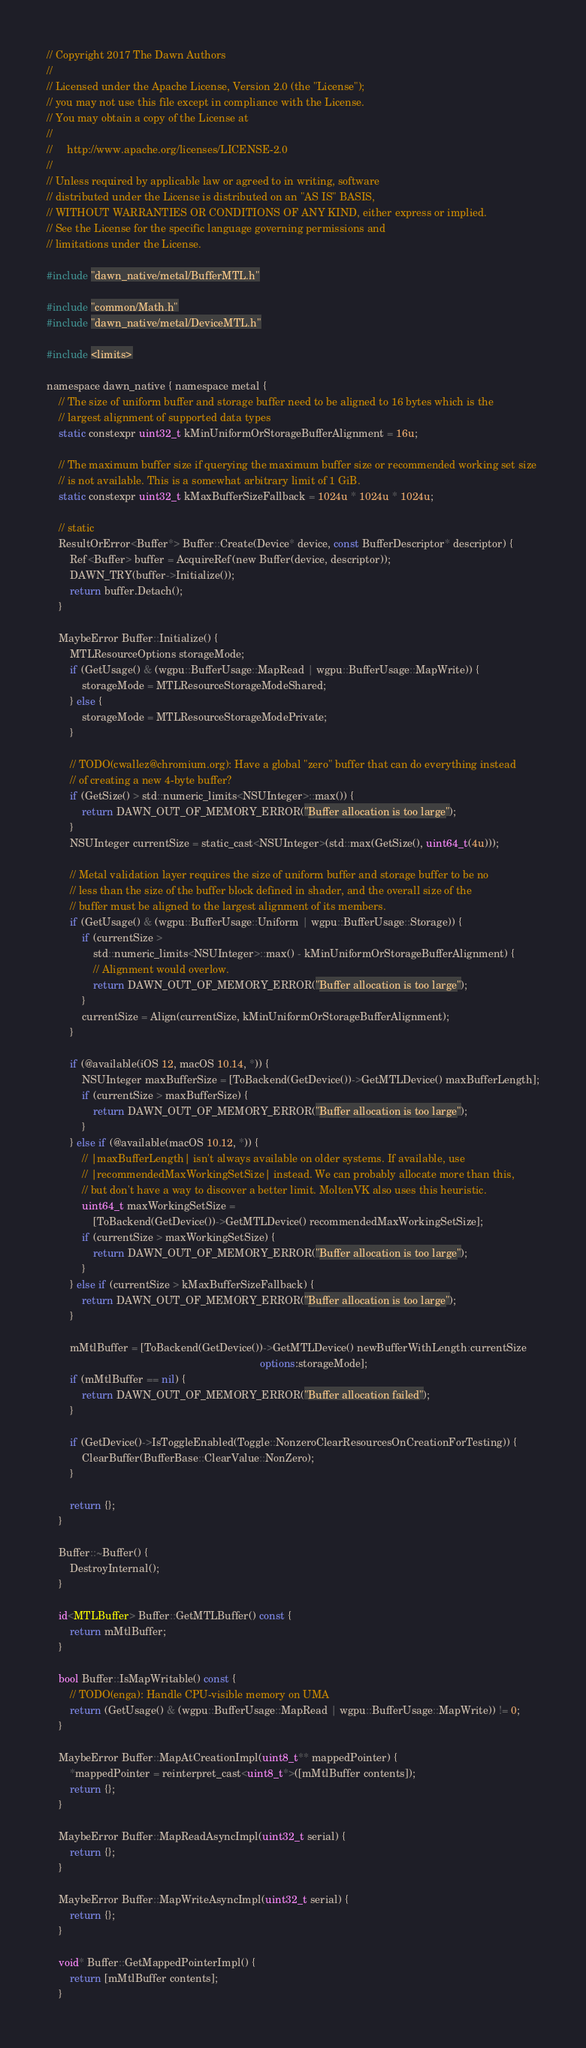<code> <loc_0><loc_0><loc_500><loc_500><_ObjectiveC_>// Copyright 2017 The Dawn Authors
//
// Licensed under the Apache License, Version 2.0 (the "License");
// you may not use this file except in compliance with the License.
// You may obtain a copy of the License at
//
//     http://www.apache.org/licenses/LICENSE-2.0
//
// Unless required by applicable law or agreed to in writing, software
// distributed under the License is distributed on an "AS IS" BASIS,
// WITHOUT WARRANTIES OR CONDITIONS OF ANY KIND, either express or implied.
// See the License for the specific language governing permissions and
// limitations under the License.

#include "dawn_native/metal/BufferMTL.h"

#include "common/Math.h"
#include "dawn_native/metal/DeviceMTL.h"

#include <limits>

namespace dawn_native { namespace metal {
    // The size of uniform buffer and storage buffer need to be aligned to 16 bytes which is the
    // largest alignment of supported data types
    static constexpr uint32_t kMinUniformOrStorageBufferAlignment = 16u;

    // The maximum buffer size if querying the maximum buffer size or recommended working set size
    // is not available. This is a somewhat arbitrary limit of 1 GiB.
    static constexpr uint32_t kMaxBufferSizeFallback = 1024u * 1024u * 1024u;

    // static
    ResultOrError<Buffer*> Buffer::Create(Device* device, const BufferDescriptor* descriptor) {
        Ref<Buffer> buffer = AcquireRef(new Buffer(device, descriptor));
        DAWN_TRY(buffer->Initialize());
        return buffer.Detach();
    }

    MaybeError Buffer::Initialize() {
        MTLResourceOptions storageMode;
        if (GetUsage() & (wgpu::BufferUsage::MapRead | wgpu::BufferUsage::MapWrite)) {
            storageMode = MTLResourceStorageModeShared;
        } else {
            storageMode = MTLResourceStorageModePrivate;
        }

        // TODO(cwallez@chromium.org): Have a global "zero" buffer that can do everything instead
        // of creating a new 4-byte buffer?
        if (GetSize() > std::numeric_limits<NSUInteger>::max()) {
            return DAWN_OUT_OF_MEMORY_ERROR("Buffer allocation is too large");
        }
        NSUInteger currentSize = static_cast<NSUInteger>(std::max(GetSize(), uint64_t(4u)));

        // Metal validation layer requires the size of uniform buffer and storage buffer to be no
        // less than the size of the buffer block defined in shader, and the overall size of the
        // buffer must be aligned to the largest alignment of its members.
        if (GetUsage() & (wgpu::BufferUsage::Uniform | wgpu::BufferUsage::Storage)) {
            if (currentSize >
                std::numeric_limits<NSUInteger>::max() - kMinUniformOrStorageBufferAlignment) {
                // Alignment would overlow.
                return DAWN_OUT_OF_MEMORY_ERROR("Buffer allocation is too large");
            }
            currentSize = Align(currentSize, kMinUniformOrStorageBufferAlignment);
        }

        if (@available(iOS 12, macOS 10.14, *)) {
            NSUInteger maxBufferSize = [ToBackend(GetDevice())->GetMTLDevice() maxBufferLength];
            if (currentSize > maxBufferSize) {
                return DAWN_OUT_OF_MEMORY_ERROR("Buffer allocation is too large");
            }
        } else if (@available(macOS 10.12, *)) {
            // |maxBufferLength| isn't always available on older systems. If available, use
            // |recommendedMaxWorkingSetSize| instead. We can probably allocate more than this,
            // but don't have a way to discover a better limit. MoltenVK also uses this heuristic.
            uint64_t maxWorkingSetSize =
                [ToBackend(GetDevice())->GetMTLDevice() recommendedMaxWorkingSetSize];
            if (currentSize > maxWorkingSetSize) {
                return DAWN_OUT_OF_MEMORY_ERROR("Buffer allocation is too large");
            }
        } else if (currentSize > kMaxBufferSizeFallback) {
            return DAWN_OUT_OF_MEMORY_ERROR("Buffer allocation is too large");
        }

        mMtlBuffer = [ToBackend(GetDevice())->GetMTLDevice() newBufferWithLength:currentSize
                                                                         options:storageMode];
        if (mMtlBuffer == nil) {
            return DAWN_OUT_OF_MEMORY_ERROR("Buffer allocation failed");
        }

        if (GetDevice()->IsToggleEnabled(Toggle::NonzeroClearResourcesOnCreationForTesting)) {
            ClearBuffer(BufferBase::ClearValue::NonZero);
        }

        return {};
    }

    Buffer::~Buffer() {
        DestroyInternal();
    }

    id<MTLBuffer> Buffer::GetMTLBuffer() const {
        return mMtlBuffer;
    }

    bool Buffer::IsMapWritable() const {
        // TODO(enga): Handle CPU-visible memory on UMA
        return (GetUsage() & (wgpu::BufferUsage::MapRead | wgpu::BufferUsage::MapWrite)) != 0;
    }

    MaybeError Buffer::MapAtCreationImpl(uint8_t** mappedPointer) {
        *mappedPointer = reinterpret_cast<uint8_t*>([mMtlBuffer contents]);
        return {};
    }

    MaybeError Buffer::MapReadAsyncImpl(uint32_t serial) {
        return {};
    }

    MaybeError Buffer::MapWriteAsyncImpl(uint32_t serial) {
        return {};
    }

    void* Buffer::GetMappedPointerImpl() {
        return [mMtlBuffer contents];
    }
</code> 